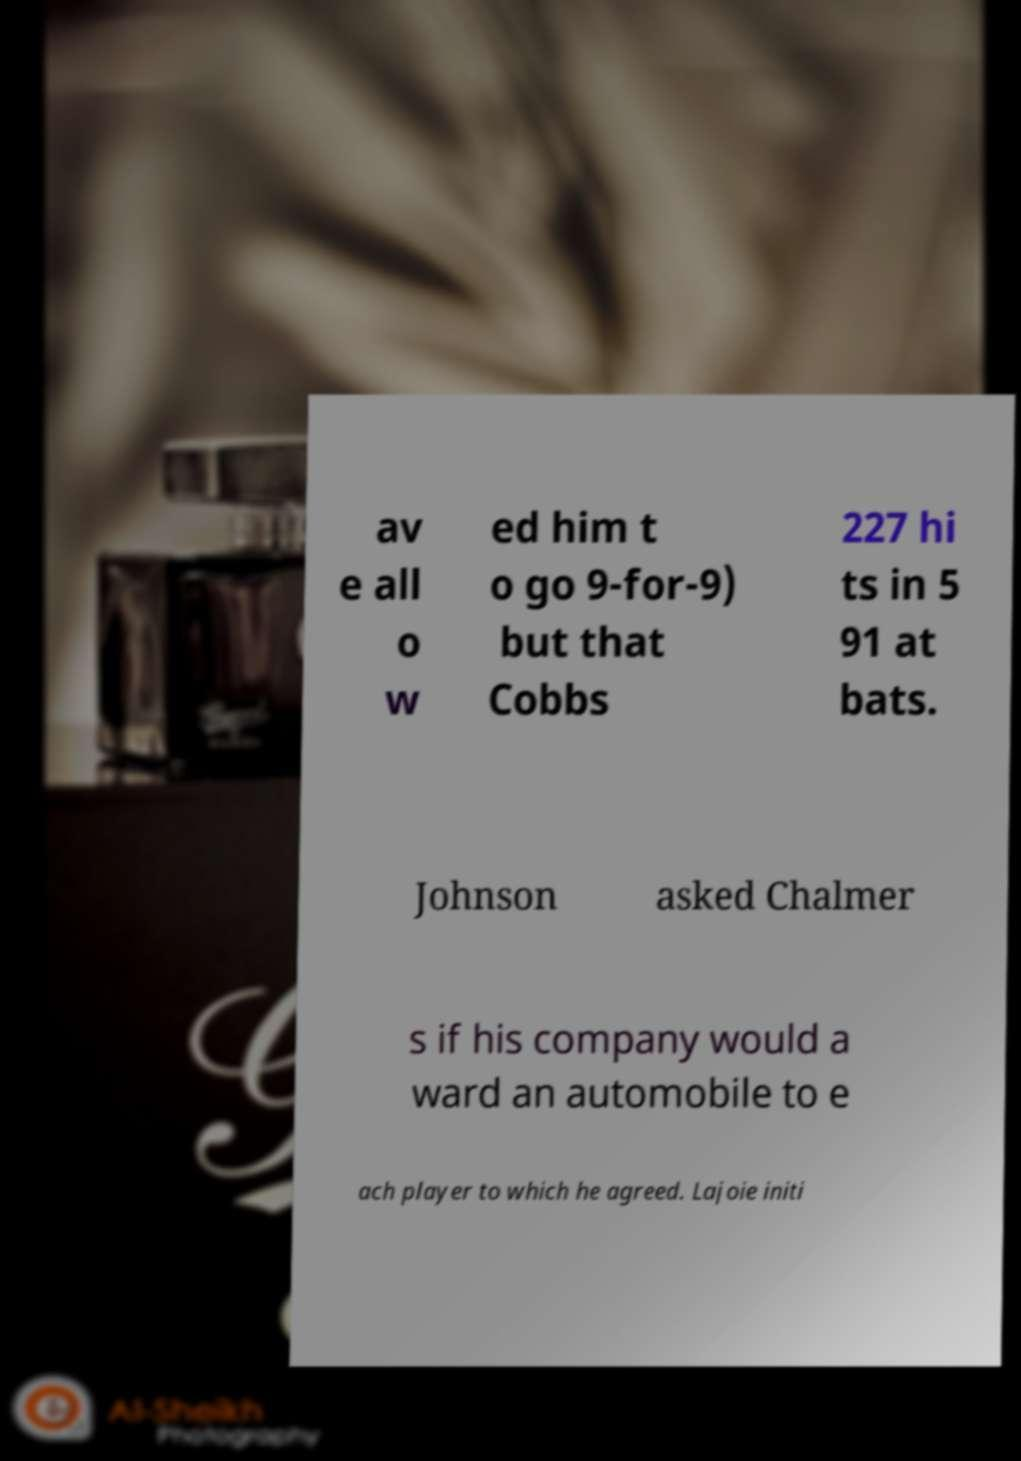There's text embedded in this image that I need extracted. Can you transcribe it verbatim? av e all o w ed him t o go 9-for-9) but that Cobbs 227 hi ts in 5 91 at bats. Johnson asked Chalmer s if his company would a ward an automobile to e ach player to which he agreed. Lajoie initi 